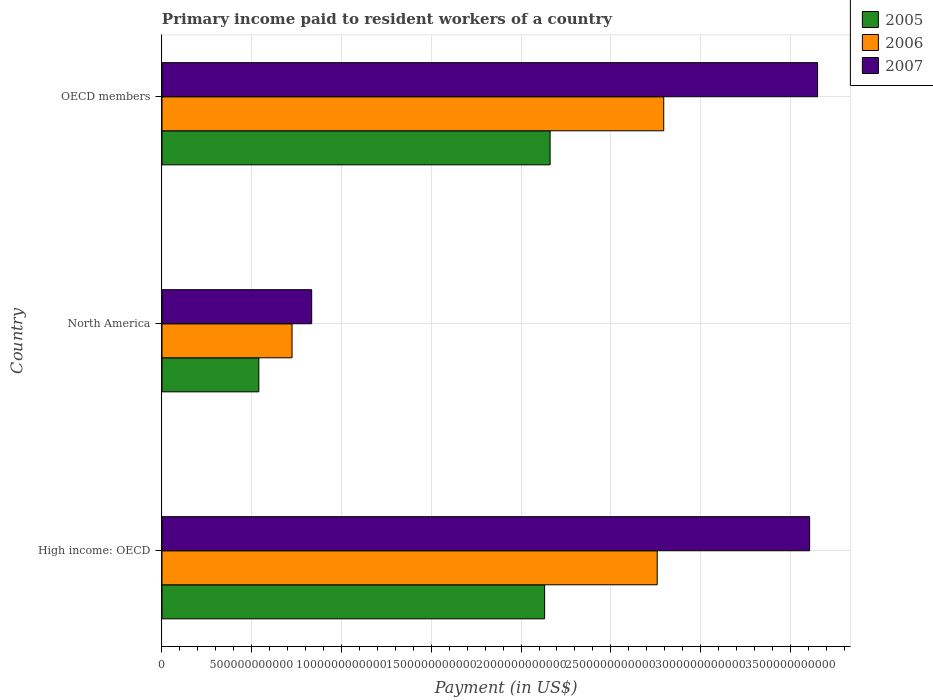How many groups of bars are there?
Your response must be concise. 3. Are the number of bars per tick equal to the number of legend labels?
Offer a very short reply. Yes. Are the number of bars on each tick of the Y-axis equal?
Your answer should be compact. Yes. How many bars are there on the 3rd tick from the top?
Ensure brevity in your answer.  3. What is the label of the 3rd group of bars from the top?
Provide a short and direct response. High income: OECD. In how many cases, is the number of bars for a given country not equal to the number of legend labels?
Keep it short and to the point. 0. What is the amount paid to workers in 2005 in OECD members?
Make the answer very short. 2.16e+12. Across all countries, what is the maximum amount paid to workers in 2005?
Make the answer very short. 2.16e+12. Across all countries, what is the minimum amount paid to workers in 2006?
Keep it short and to the point. 7.24e+11. In which country was the amount paid to workers in 2005 maximum?
Your answer should be compact. OECD members. What is the total amount paid to workers in 2006 in the graph?
Your response must be concise. 6.28e+12. What is the difference between the amount paid to workers in 2006 in High income: OECD and that in OECD members?
Give a very brief answer. -3.64e+1. What is the difference between the amount paid to workers in 2007 in High income: OECD and the amount paid to workers in 2005 in OECD members?
Give a very brief answer. 1.45e+12. What is the average amount paid to workers in 2007 per country?
Your answer should be compact. 2.70e+12. What is the difference between the amount paid to workers in 2006 and amount paid to workers in 2007 in North America?
Your response must be concise. -1.09e+11. What is the ratio of the amount paid to workers in 2005 in North America to that in OECD members?
Your answer should be very brief. 0.25. Is the amount paid to workers in 2007 in North America less than that in OECD members?
Your answer should be compact. Yes. Is the difference between the amount paid to workers in 2006 in High income: OECD and North America greater than the difference between the amount paid to workers in 2007 in High income: OECD and North America?
Give a very brief answer. No. What is the difference between the highest and the second highest amount paid to workers in 2007?
Keep it short and to the point. 4.43e+1. What is the difference between the highest and the lowest amount paid to workers in 2005?
Give a very brief answer. 1.62e+12. In how many countries, is the amount paid to workers in 2006 greater than the average amount paid to workers in 2006 taken over all countries?
Provide a short and direct response. 2. Is the sum of the amount paid to workers in 2005 in High income: OECD and OECD members greater than the maximum amount paid to workers in 2007 across all countries?
Provide a succinct answer. Yes. What does the 3rd bar from the top in High income: OECD represents?
Give a very brief answer. 2005. Is it the case that in every country, the sum of the amount paid to workers in 2007 and amount paid to workers in 2005 is greater than the amount paid to workers in 2006?
Your answer should be very brief. Yes. Are all the bars in the graph horizontal?
Your answer should be very brief. Yes. What is the difference between two consecutive major ticks on the X-axis?
Your answer should be very brief. 5.00e+11. Are the values on the major ticks of X-axis written in scientific E-notation?
Provide a short and direct response. No. Does the graph contain any zero values?
Keep it short and to the point. No. How many legend labels are there?
Ensure brevity in your answer.  3. How are the legend labels stacked?
Your answer should be compact. Vertical. What is the title of the graph?
Ensure brevity in your answer.  Primary income paid to resident workers of a country. What is the label or title of the X-axis?
Provide a succinct answer. Payment (in US$). What is the Payment (in US$) of 2005 in High income: OECD?
Keep it short and to the point. 2.13e+12. What is the Payment (in US$) of 2006 in High income: OECD?
Provide a succinct answer. 2.76e+12. What is the Payment (in US$) of 2007 in High income: OECD?
Keep it short and to the point. 3.61e+12. What is the Payment (in US$) of 2005 in North America?
Offer a terse response. 5.39e+11. What is the Payment (in US$) in 2006 in North America?
Offer a terse response. 7.24e+11. What is the Payment (in US$) of 2007 in North America?
Provide a short and direct response. 8.34e+11. What is the Payment (in US$) of 2005 in OECD members?
Give a very brief answer. 2.16e+12. What is the Payment (in US$) of 2006 in OECD members?
Make the answer very short. 2.79e+12. What is the Payment (in US$) in 2007 in OECD members?
Your response must be concise. 3.65e+12. Across all countries, what is the maximum Payment (in US$) in 2005?
Your response must be concise. 2.16e+12. Across all countries, what is the maximum Payment (in US$) in 2006?
Give a very brief answer. 2.79e+12. Across all countries, what is the maximum Payment (in US$) in 2007?
Offer a terse response. 3.65e+12. Across all countries, what is the minimum Payment (in US$) of 2005?
Your response must be concise. 5.39e+11. Across all countries, what is the minimum Payment (in US$) in 2006?
Provide a succinct answer. 7.24e+11. Across all countries, what is the minimum Payment (in US$) of 2007?
Your response must be concise. 8.34e+11. What is the total Payment (in US$) in 2005 in the graph?
Make the answer very short. 4.83e+12. What is the total Payment (in US$) in 2006 in the graph?
Provide a short and direct response. 6.28e+12. What is the total Payment (in US$) in 2007 in the graph?
Your answer should be compact. 8.09e+12. What is the difference between the Payment (in US$) in 2005 in High income: OECD and that in North America?
Your answer should be compact. 1.59e+12. What is the difference between the Payment (in US$) in 2006 in High income: OECD and that in North America?
Make the answer very short. 2.03e+12. What is the difference between the Payment (in US$) in 2007 in High income: OECD and that in North America?
Keep it short and to the point. 2.77e+12. What is the difference between the Payment (in US$) in 2005 in High income: OECD and that in OECD members?
Your answer should be compact. -3.07e+1. What is the difference between the Payment (in US$) of 2006 in High income: OECD and that in OECD members?
Make the answer very short. -3.64e+1. What is the difference between the Payment (in US$) of 2007 in High income: OECD and that in OECD members?
Make the answer very short. -4.43e+1. What is the difference between the Payment (in US$) in 2005 in North America and that in OECD members?
Give a very brief answer. -1.62e+12. What is the difference between the Payment (in US$) of 2006 in North America and that in OECD members?
Give a very brief answer. -2.07e+12. What is the difference between the Payment (in US$) of 2007 in North America and that in OECD members?
Offer a very short reply. -2.82e+12. What is the difference between the Payment (in US$) of 2005 in High income: OECD and the Payment (in US$) of 2006 in North America?
Give a very brief answer. 1.41e+12. What is the difference between the Payment (in US$) of 2005 in High income: OECD and the Payment (in US$) of 2007 in North America?
Your answer should be very brief. 1.30e+12. What is the difference between the Payment (in US$) in 2006 in High income: OECD and the Payment (in US$) in 2007 in North America?
Offer a very short reply. 1.92e+12. What is the difference between the Payment (in US$) in 2005 in High income: OECD and the Payment (in US$) in 2006 in OECD members?
Make the answer very short. -6.64e+11. What is the difference between the Payment (in US$) in 2005 in High income: OECD and the Payment (in US$) in 2007 in OECD members?
Your answer should be very brief. -1.52e+12. What is the difference between the Payment (in US$) in 2006 in High income: OECD and the Payment (in US$) in 2007 in OECD members?
Keep it short and to the point. -8.93e+11. What is the difference between the Payment (in US$) in 2005 in North America and the Payment (in US$) in 2006 in OECD members?
Your answer should be compact. -2.26e+12. What is the difference between the Payment (in US$) in 2005 in North America and the Payment (in US$) in 2007 in OECD members?
Provide a succinct answer. -3.11e+12. What is the difference between the Payment (in US$) in 2006 in North America and the Payment (in US$) in 2007 in OECD members?
Keep it short and to the point. -2.93e+12. What is the average Payment (in US$) of 2005 per country?
Ensure brevity in your answer.  1.61e+12. What is the average Payment (in US$) in 2006 per country?
Your response must be concise. 2.09e+12. What is the average Payment (in US$) in 2007 per country?
Provide a succinct answer. 2.70e+12. What is the difference between the Payment (in US$) of 2005 and Payment (in US$) of 2006 in High income: OECD?
Offer a terse response. -6.27e+11. What is the difference between the Payment (in US$) of 2005 and Payment (in US$) of 2007 in High income: OECD?
Provide a short and direct response. -1.48e+12. What is the difference between the Payment (in US$) in 2006 and Payment (in US$) in 2007 in High income: OECD?
Your answer should be very brief. -8.49e+11. What is the difference between the Payment (in US$) in 2005 and Payment (in US$) in 2006 in North America?
Give a very brief answer. -1.85e+11. What is the difference between the Payment (in US$) of 2005 and Payment (in US$) of 2007 in North America?
Your response must be concise. -2.94e+11. What is the difference between the Payment (in US$) in 2006 and Payment (in US$) in 2007 in North America?
Provide a short and direct response. -1.09e+11. What is the difference between the Payment (in US$) of 2005 and Payment (in US$) of 2006 in OECD members?
Make the answer very short. -6.33e+11. What is the difference between the Payment (in US$) of 2005 and Payment (in US$) of 2007 in OECD members?
Provide a succinct answer. -1.49e+12. What is the difference between the Payment (in US$) of 2006 and Payment (in US$) of 2007 in OECD members?
Make the answer very short. -8.57e+11. What is the ratio of the Payment (in US$) of 2005 in High income: OECD to that in North America?
Keep it short and to the point. 3.95. What is the ratio of the Payment (in US$) in 2006 in High income: OECD to that in North America?
Your answer should be compact. 3.81. What is the ratio of the Payment (in US$) in 2007 in High income: OECD to that in North America?
Provide a short and direct response. 4.33. What is the ratio of the Payment (in US$) of 2005 in High income: OECD to that in OECD members?
Give a very brief answer. 0.99. What is the ratio of the Payment (in US$) in 2007 in High income: OECD to that in OECD members?
Give a very brief answer. 0.99. What is the ratio of the Payment (in US$) in 2005 in North America to that in OECD members?
Keep it short and to the point. 0.25. What is the ratio of the Payment (in US$) in 2006 in North America to that in OECD members?
Your answer should be compact. 0.26. What is the ratio of the Payment (in US$) in 2007 in North America to that in OECD members?
Provide a short and direct response. 0.23. What is the difference between the highest and the second highest Payment (in US$) of 2005?
Offer a terse response. 3.07e+1. What is the difference between the highest and the second highest Payment (in US$) in 2006?
Give a very brief answer. 3.64e+1. What is the difference between the highest and the second highest Payment (in US$) of 2007?
Your answer should be compact. 4.43e+1. What is the difference between the highest and the lowest Payment (in US$) of 2005?
Your answer should be very brief. 1.62e+12. What is the difference between the highest and the lowest Payment (in US$) in 2006?
Offer a terse response. 2.07e+12. What is the difference between the highest and the lowest Payment (in US$) of 2007?
Offer a very short reply. 2.82e+12. 